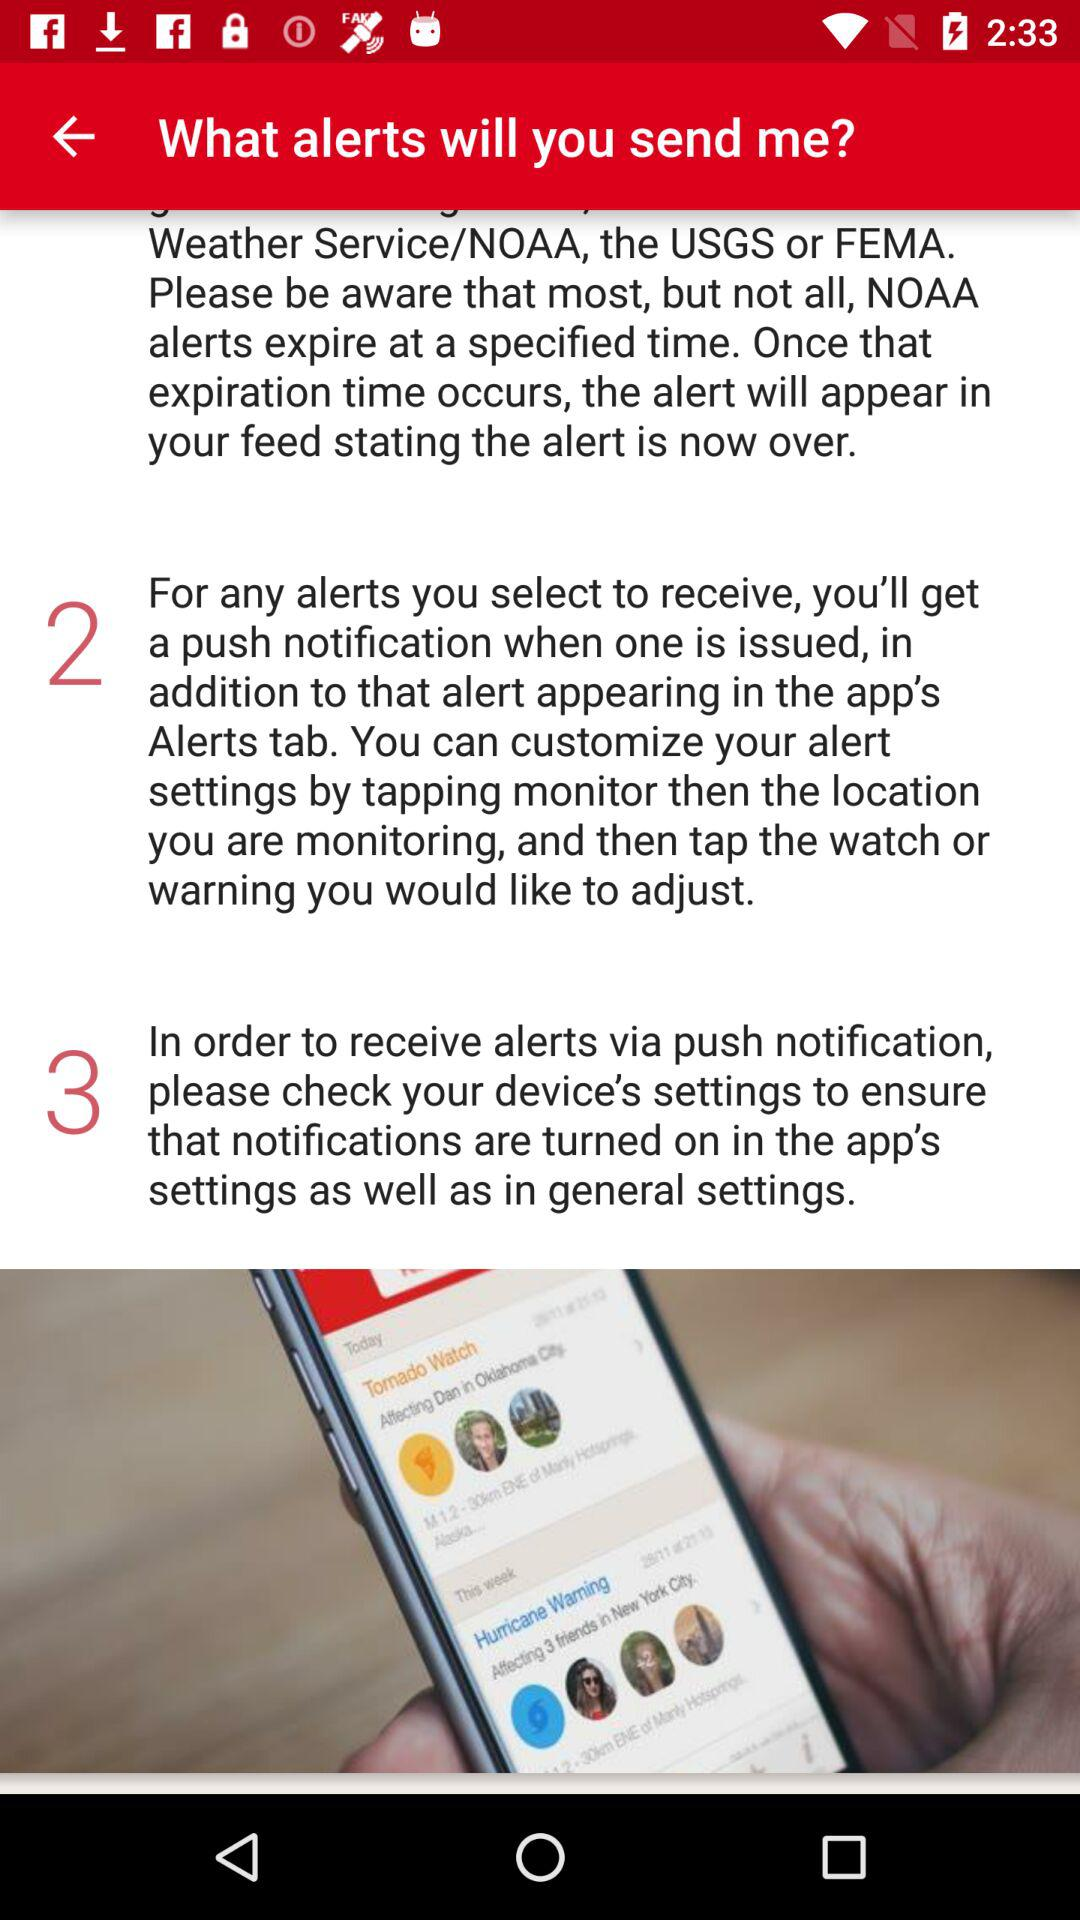How many steps are there in the process of receiving an alert?
Answer the question using a single word or phrase. 3 